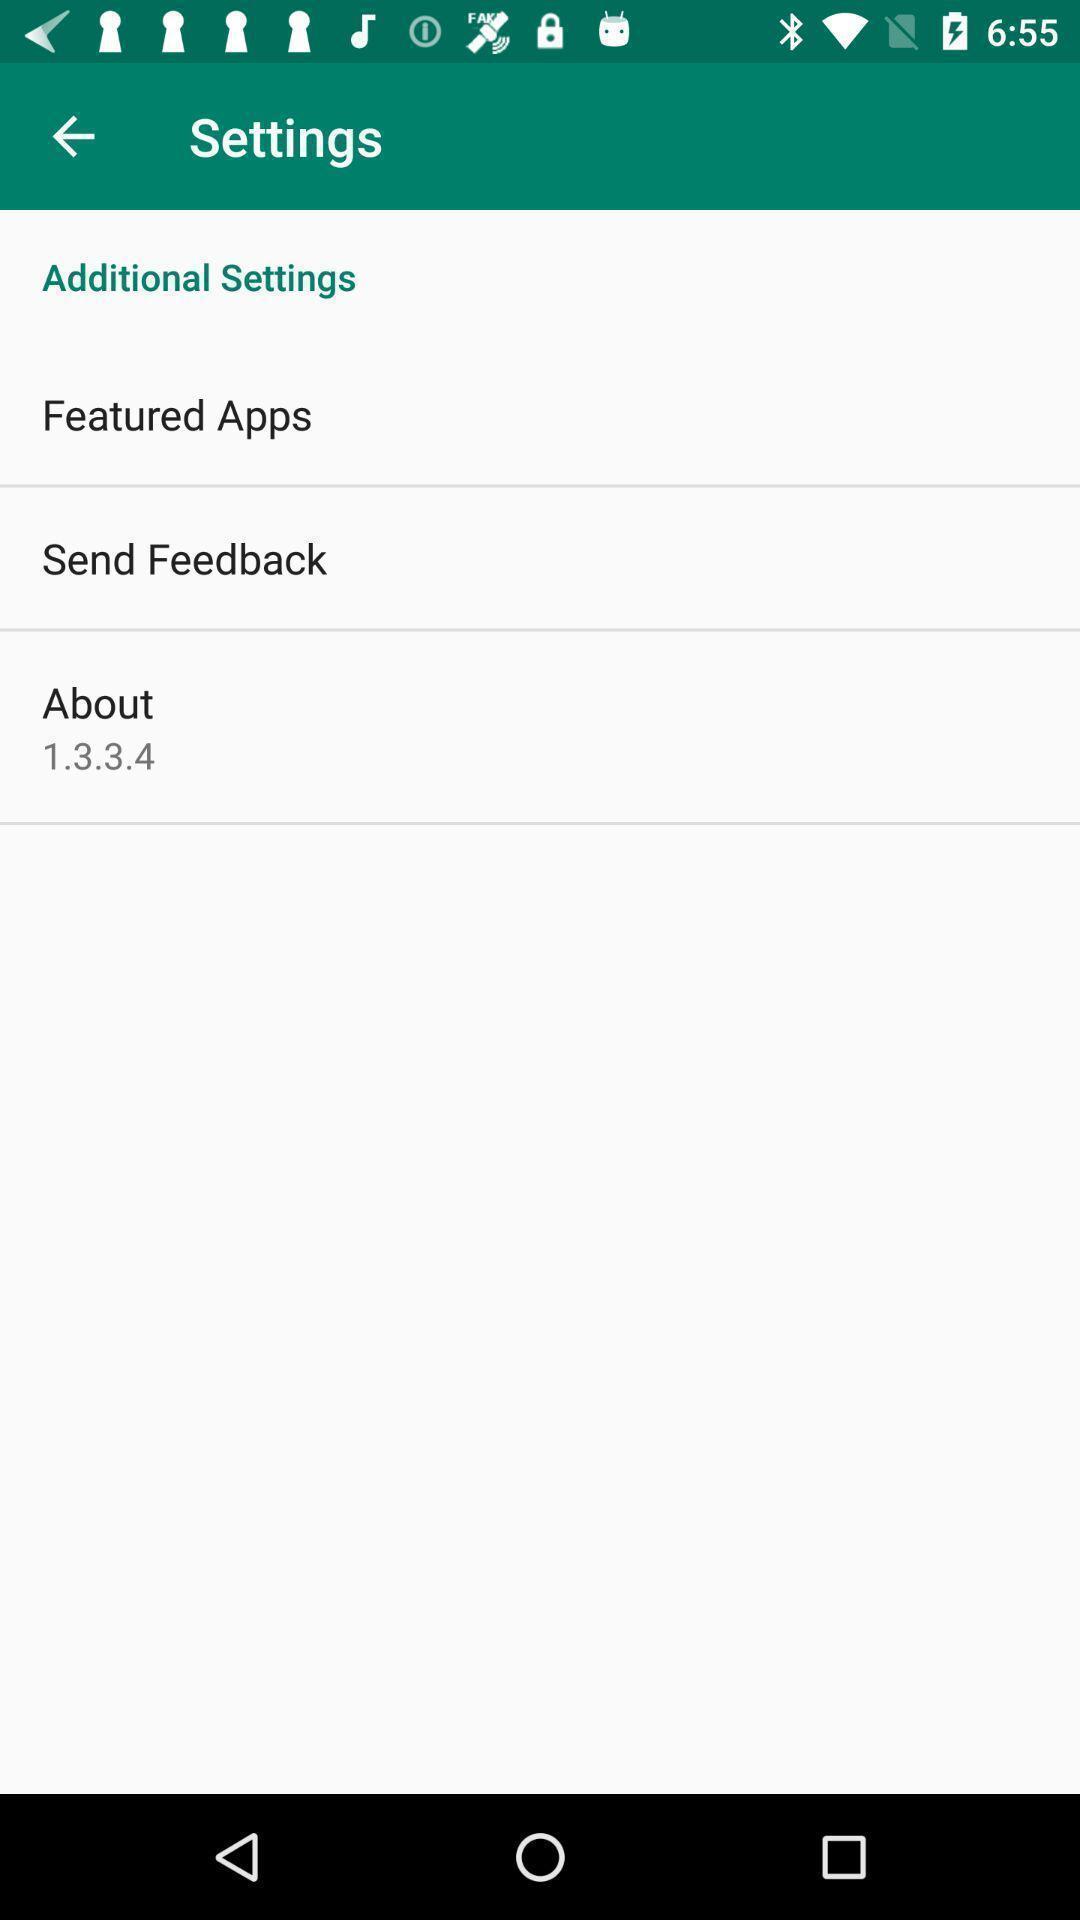What details can you identify in this image? Settings page with other options. 